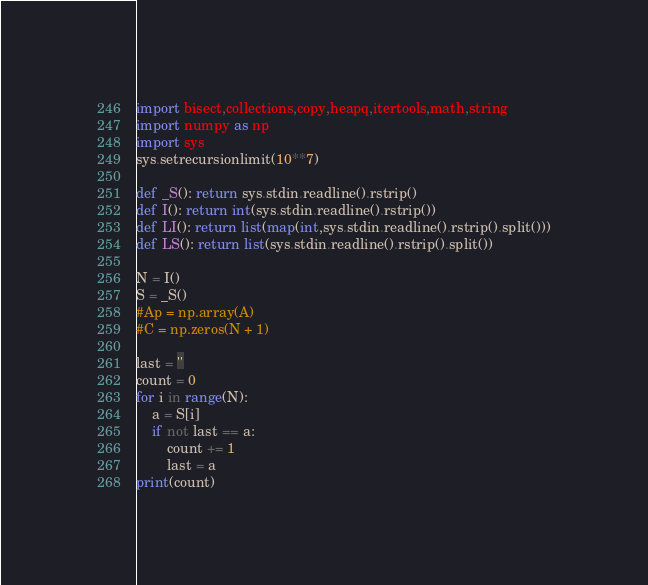Convert code to text. <code><loc_0><loc_0><loc_500><loc_500><_Python_>import bisect,collections,copy,heapq,itertools,math,string
import numpy as np
import sys
sys.setrecursionlimit(10**7)

def _S(): return sys.stdin.readline().rstrip()
def I(): return int(sys.stdin.readline().rstrip())
def LI(): return list(map(int,sys.stdin.readline().rstrip().split()))
def LS(): return list(sys.stdin.readline().rstrip().split())

N = I()
S = _S()
#Ap = np.array(A)
#C = np.zeros(N + 1)

last = ''
count = 0
for i in range(N):
    a = S[i]
    if not last == a:
        count += 1
        last = a
print(count)</code> 